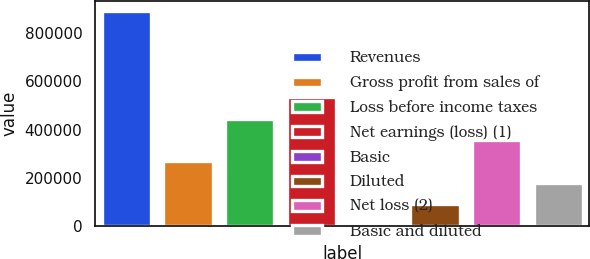<chart> <loc_0><loc_0><loc_500><loc_500><bar_chart><fcel>Revenues<fcel>Gross profit from sales of<fcel>Loss before income taxes<fcel>Net earnings (loss) (1)<fcel>Basic<fcel>Diluted<fcel>Net loss (2)<fcel>Basic and diluted<nl><fcel>891853<fcel>267556<fcel>445927<fcel>535112<fcel>0.76<fcel>89186<fcel>356742<fcel>178371<nl></chart> 